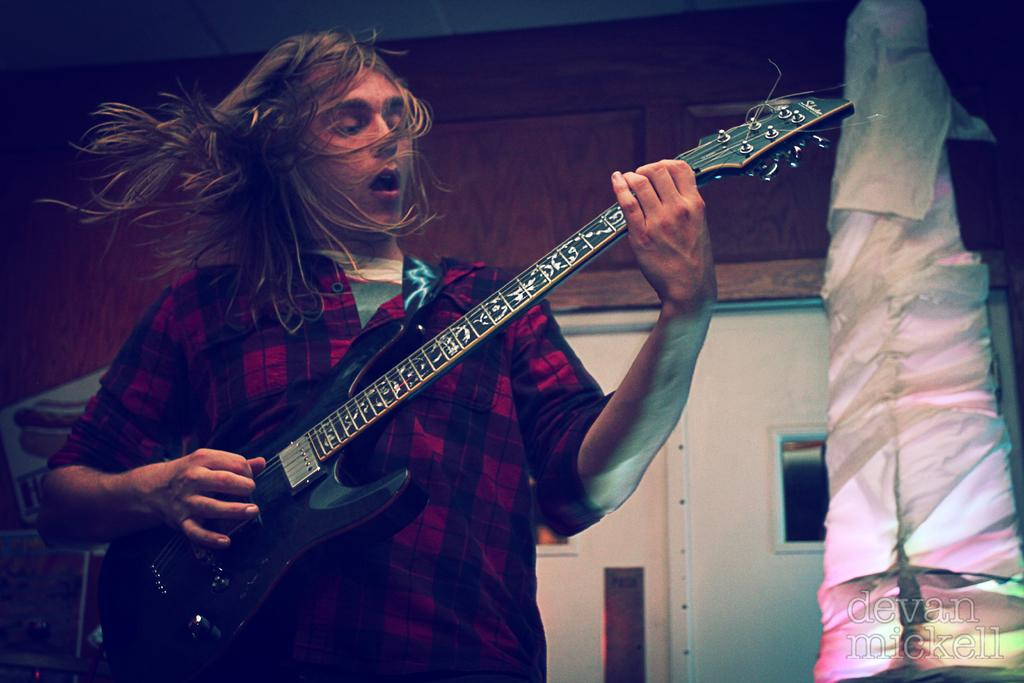Who is the main subject in the image? There is a boy in the image. Where is the boy located in the image? The boy is on the left side of the image. What is the boy doing in the image? The boy is playing the guitar. What can be seen behind the boy in the image? There is a door behind the boy. What might the boy's expression suggest about his feelings or intentions? The boy's expression suggests he is expressing something. What type of hat is the boy wearing in the image? There is no hat visible in the image; the boy is playing the guitar with his head uncovered. 